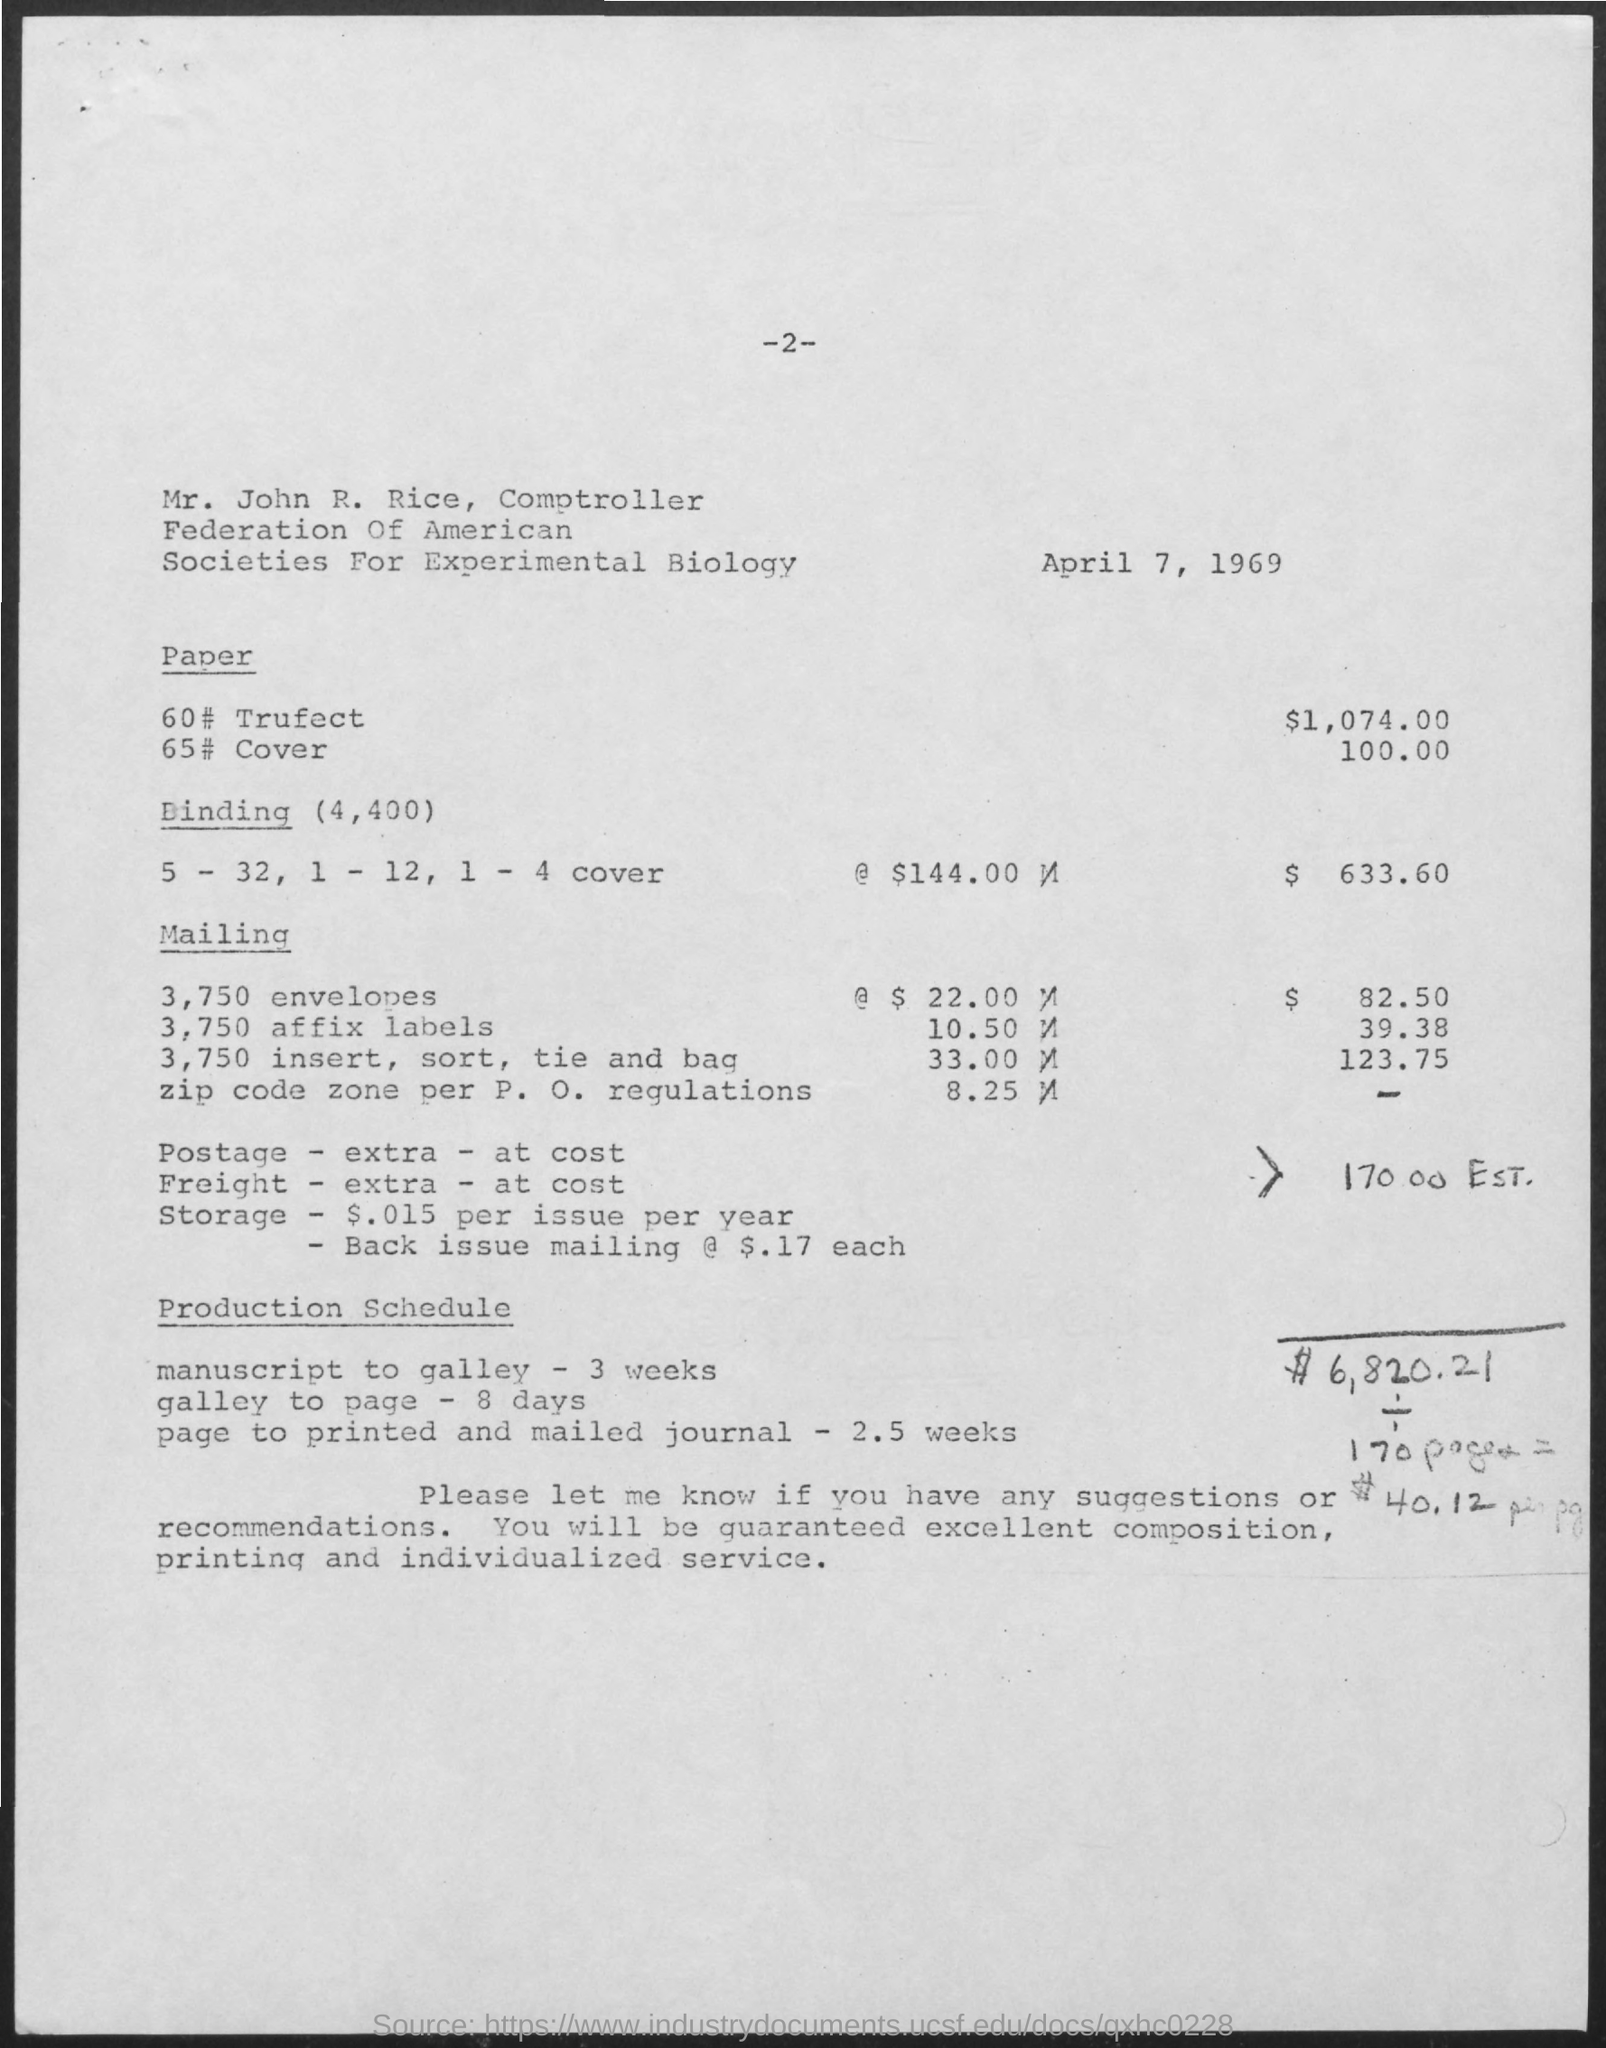Identify some key points in this picture. The page number at the top of the page is 2. The cost of Paper 60# Trufect is $1,074.00. The Comptroller of the Federation of American Societies for Experimental Biology is Mr. John R. Rice. April 7th, 1969 is mentioned at the top of the page. The cost of binding is $633.60. 